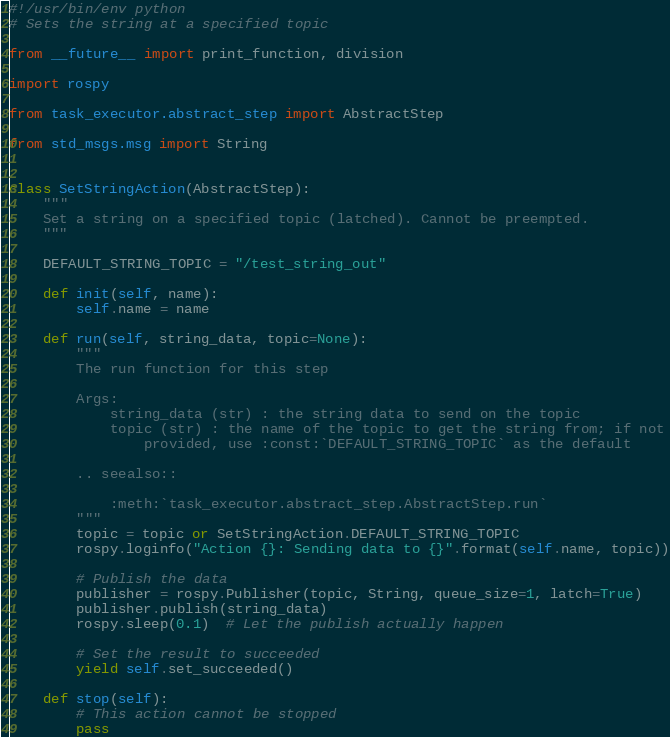<code> <loc_0><loc_0><loc_500><loc_500><_Python_>#!/usr/bin/env python
# Sets the string at a specified topic

from __future__ import print_function, division

import rospy

from task_executor.abstract_step import AbstractStep

from std_msgs.msg import String


class SetStringAction(AbstractStep):
    """
    Set a string on a specified topic (latched). Cannot be preempted.
    """

    DEFAULT_STRING_TOPIC = "/test_string_out"

    def init(self, name):
        self.name = name

    def run(self, string_data, topic=None):
        """
        The run function for this step

        Args:
            string_data (str) : the string data to send on the topic
            topic (str) : the name of the topic to get the string from; if not
                provided, use :const:`DEFAULT_STRING_TOPIC` as the default

        .. seealso::

            :meth:`task_executor.abstract_step.AbstractStep.run`
        """
        topic = topic or SetStringAction.DEFAULT_STRING_TOPIC
        rospy.loginfo("Action {}: Sending data to {}".format(self.name, topic))

        # Publish the data
        publisher = rospy.Publisher(topic, String, queue_size=1, latch=True)
        publisher.publish(string_data)
        rospy.sleep(0.1)  # Let the publish actually happen

        # Set the result to succeeded
        yield self.set_succeeded()

    def stop(self):
        # This action cannot be stopped
        pass
</code> 